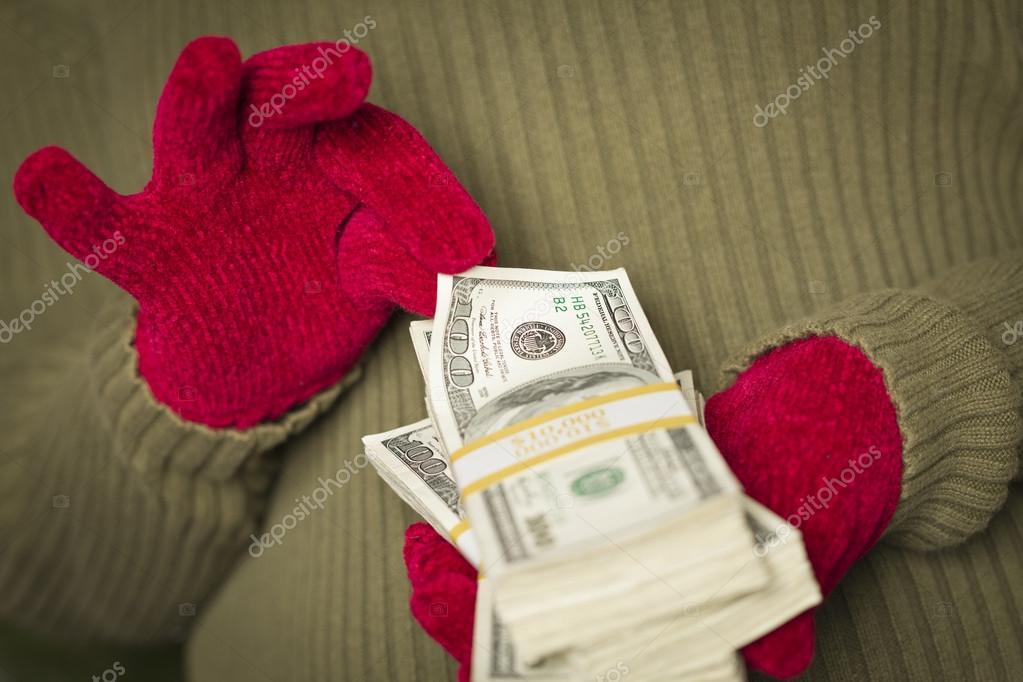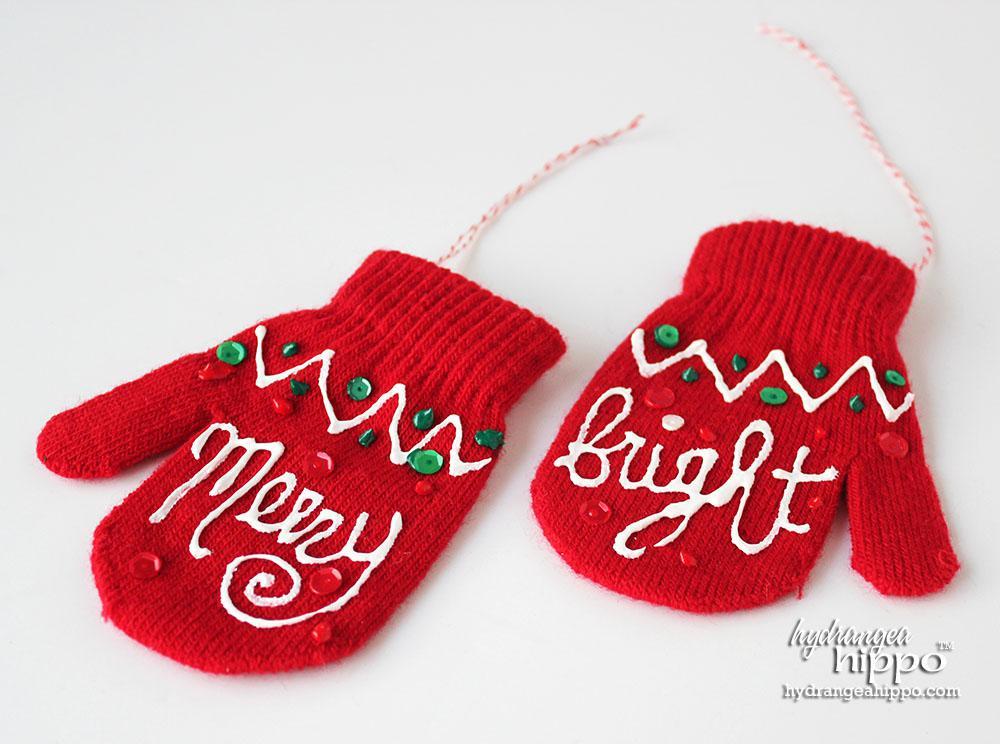The first image is the image on the left, the second image is the image on the right. Examine the images to the left and right. Is the description "The left and right image contains the same number of red mittens." accurate? Answer yes or no. Yes. The first image is the image on the left, the second image is the image on the right. Given the left and right images, does the statement "An image shows exactly three unworn items of apparel, and at least two are gloves with fingers." hold true? Answer yes or no. No. 